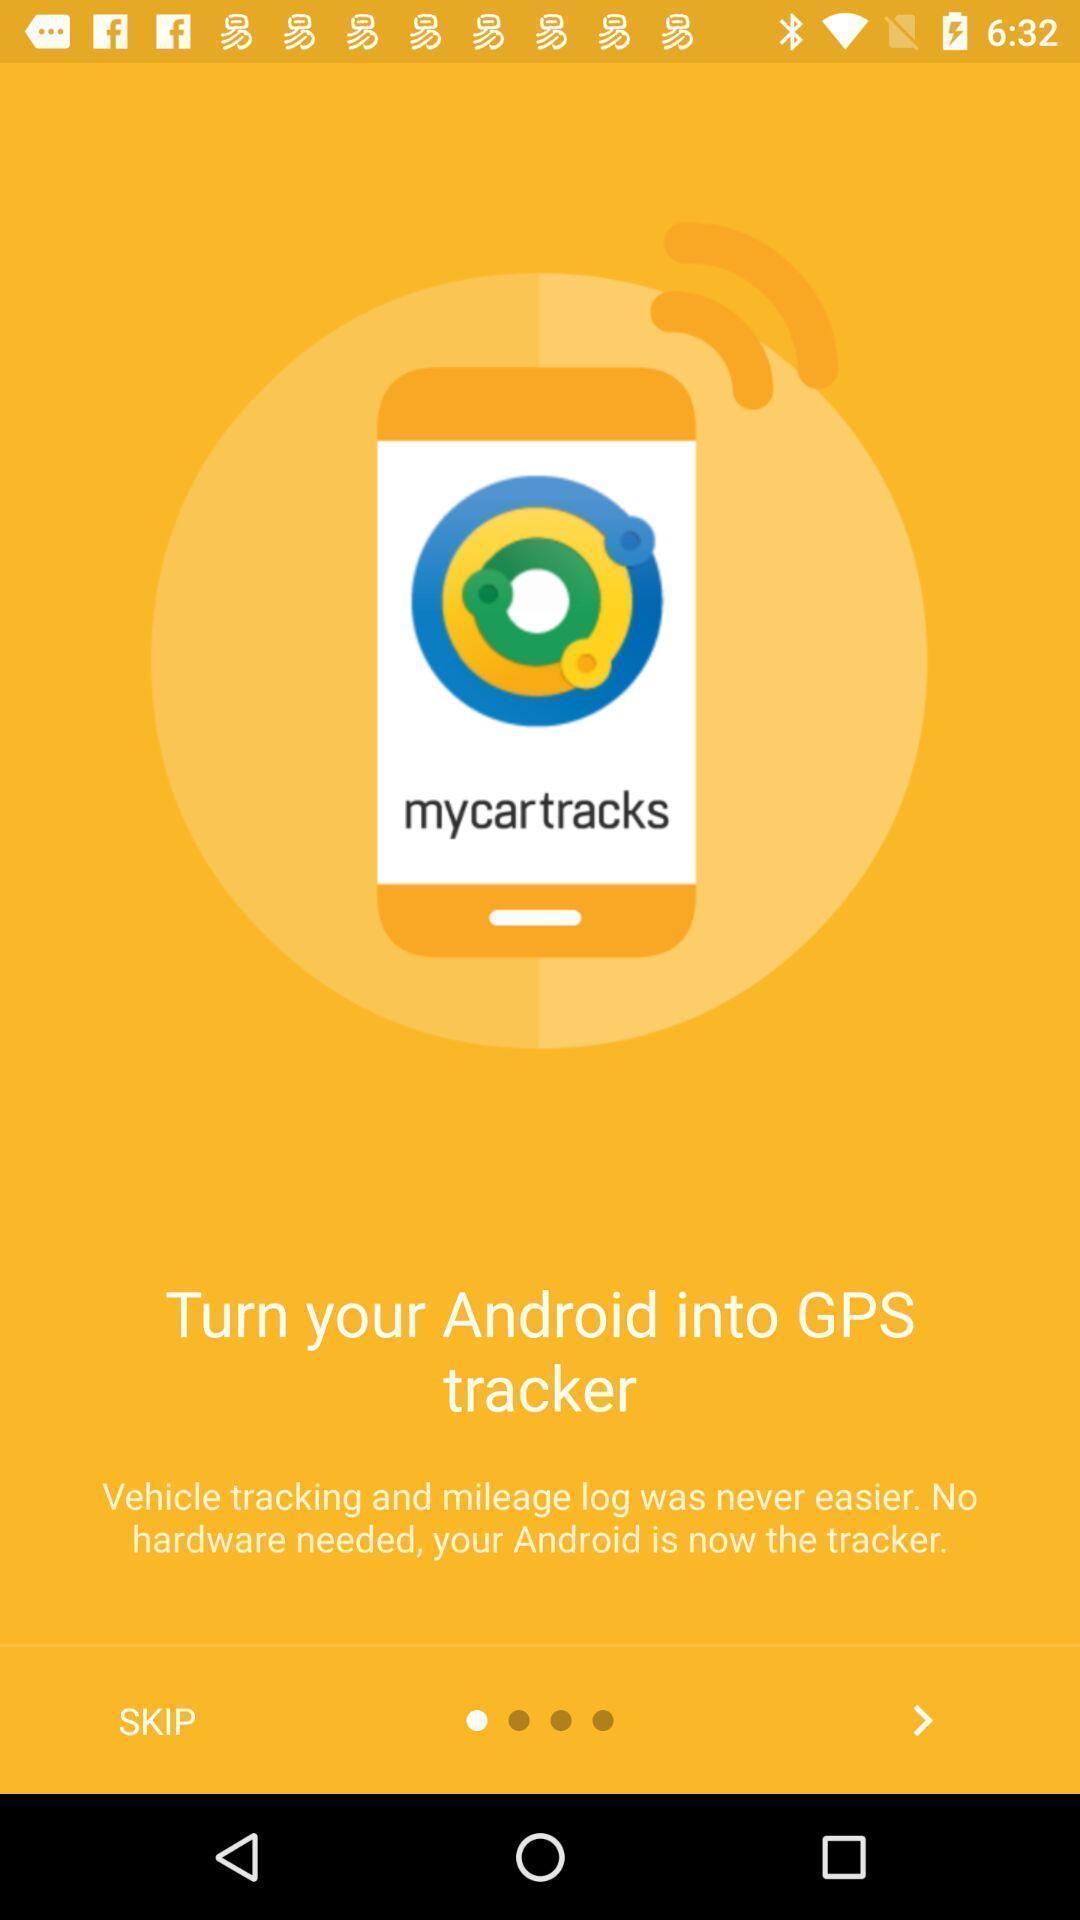Give me a narrative description of this picture. Welcome page for the vehicle tracking app. 